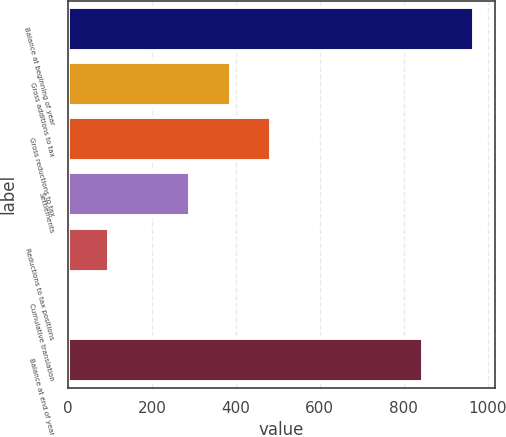<chart> <loc_0><loc_0><loc_500><loc_500><bar_chart><fcel>Balance at beginning of year<fcel>Gross additions to tax<fcel>Gross reductions to tax<fcel>Settlements<fcel>Reductions to tax positions<fcel>Cumulative translation<fcel>Balance at end of year<nl><fcel>968<fcel>387.8<fcel>484.5<fcel>291.1<fcel>97.7<fcel>1<fcel>845<nl></chart> 